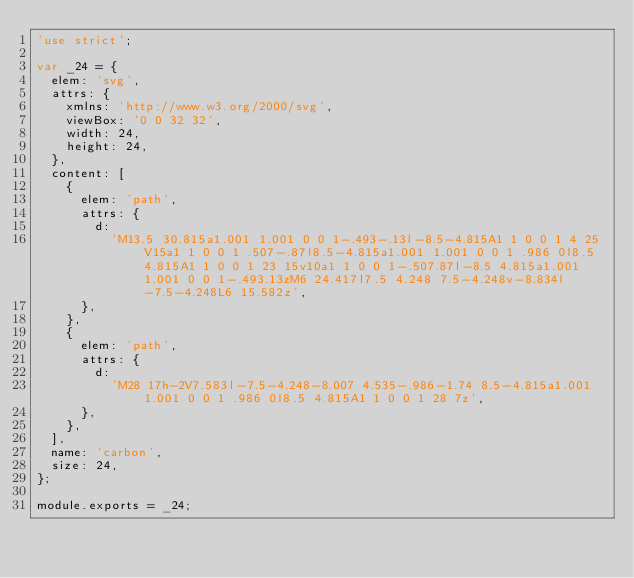<code> <loc_0><loc_0><loc_500><loc_500><_JavaScript_>'use strict';

var _24 = {
  elem: 'svg',
  attrs: {
    xmlns: 'http://www.w3.org/2000/svg',
    viewBox: '0 0 32 32',
    width: 24,
    height: 24,
  },
  content: [
    {
      elem: 'path',
      attrs: {
        d:
          'M13.5 30.815a1.001 1.001 0 0 1-.493-.13l-8.5-4.815A1 1 0 0 1 4 25V15a1 1 0 0 1 .507-.87l8.5-4.815a1.001 1.001 0 0 1 .986 0l8.5 4.815A1 1 0 0 1 23 15v10a1 1 0 0 1-.507.87l-8.5 4.815a1.001 1.001 0 0 1-.493.13zM6 24.417l7.5 4.248 7.5-4.248v-8.834l-7.5-4.248L6 15.582z',
      },
    },
    {
      elem: 'path',
      attrs: {
        d:
          'M28 17h-2V7.583l-7.5-4.248-8.007 4.535-.986-1.74 8.5-4.815a1.001 1.001 0 0 1 .986 0l8.5 4.815A1 1 0 0 1 28 7z',
      },
    },
  ],
  name: 'carbon',
  size: 24,
};

module.exports = _24;
</code> 